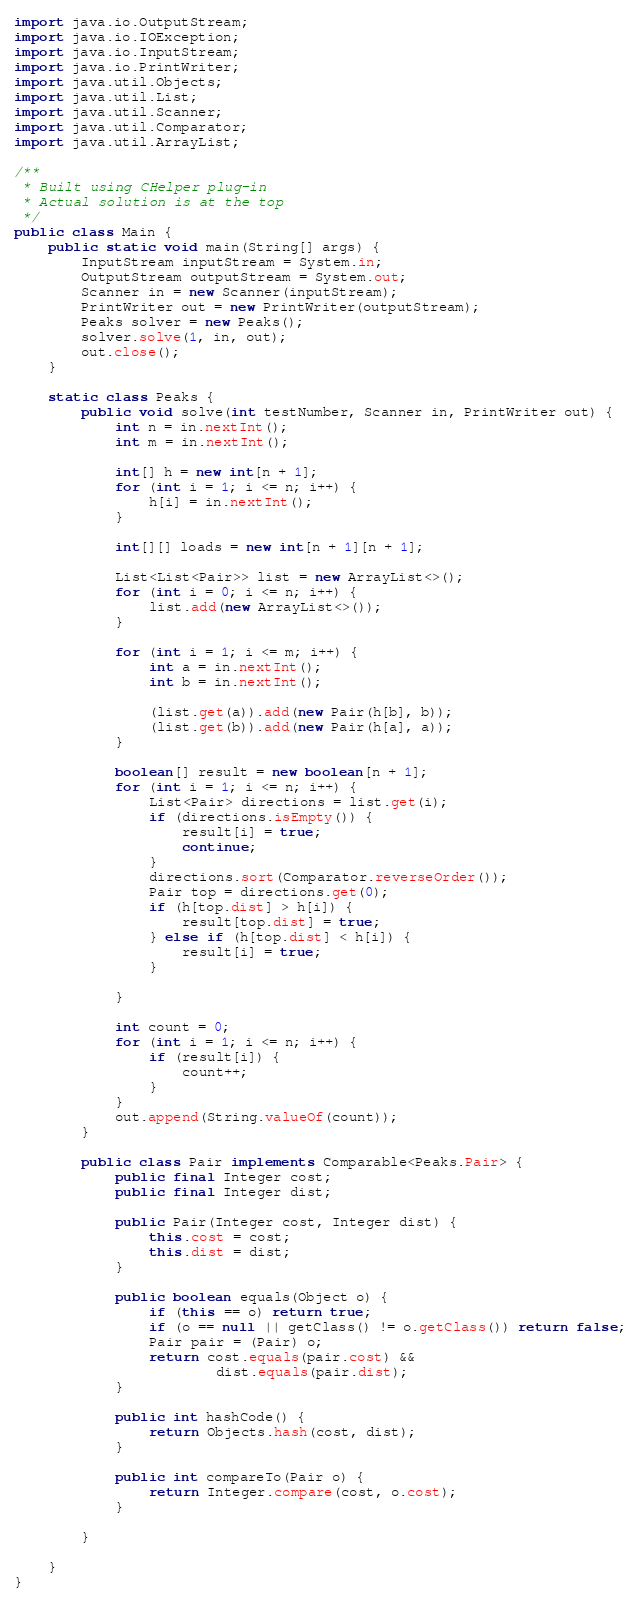Convert code to text. <code><loc_0><loc_0><loc_500><loc_500><_Java_>import java.io.OutputStream;
import java.io.IOException;
import java.io.InputStream;
import java.io.PrintWriter;
import java.util.Objects;
import java.util.List;
import java.util.Scanner;
import java.util.Comparator;
import java.util.ArrayList;

/**
 * Built using CHelper plug-in
 * Actual solution is at the top
 */
public class Main {
    public static void main(String[] args) {
        InputStream inputStream = System.in;
        OutputStream outputStream = System.out;
        Scanner in = new Scanner(inputStream);
        PrintWriter out = new PrintWriter(outputStream);
        Peaks solver = new Peaks();
        solver.solve(1, in, out);
        out.close();
    }

    static class Peaks {
        public void solve(int testNumber, Scanner in, PrintWriter out) {
            int n = in.nextInt();
            int m = in.nextInt();

            int[] h = new int[n + 1];
            for (int i = 1; i <= n; i++) {
                h[i] = in.nextInt();
            }

            int[][] loads = new int[n + 1][n + 1];

            List<List<Pair>> list = new ArrayList<>();
            for (int i = 0; i <= n; i++) {
                list.add(new ArrayList<>());
            }

            for (int i = 1; i <= m; i++) {
                int a = in.nextInt();
                int b = in.nextInt();

                (list.get(a)).add(new Pair(h[b], b));
                (list.get(b)).add(new Pair(h[a], a));
            }

            boolean[] result = new boolean[n + 1];
            for (int i = 1; i <= n; i++) {
                List<Pair> directions = list.get(i);
                if (directions.isEmpty()) {
                    result[i] = true;
                    continue;
                }
                directions.sort(Comparator.reverseOrder());
                Pair top = directions.get(0);
                if (h[top.dist] > h[i]) {
                    result[top.dist] = true;
                } else if (h[top.dist] < h[i]) {
                    result[i] = true;
                }

            }

            int count = 0;
            for (int i = 1; i <= n; i++) {
                if (result[i]) {
                    count++;
                }
            }
            out.append(String.valueOf(count));
        }

        public class Pair implements Comparable<Peaks.Pair> {
            public final Integer cost;
            public final Integer dist;

            public Pair(Integer cost, Integer dist) {
                this.cost = cost;
                this.dist = dist;
            }

            public boolean equals(Object o) {
                if (this == o) return true;
                if (o == null || getClass() != o.getClass()) return false;
                Pair pair = (Pair) o;
                return cost.equals(pair.cost) &&
                        dist.equals(pair.dist);
            }

            public int hashCode() {
                return Objects.hash(cost, dist);
            }

            public int compareTo(Pair o) {
                return Integer.compare(cost, o.cost);
            }

        }

    }
}

</code> 